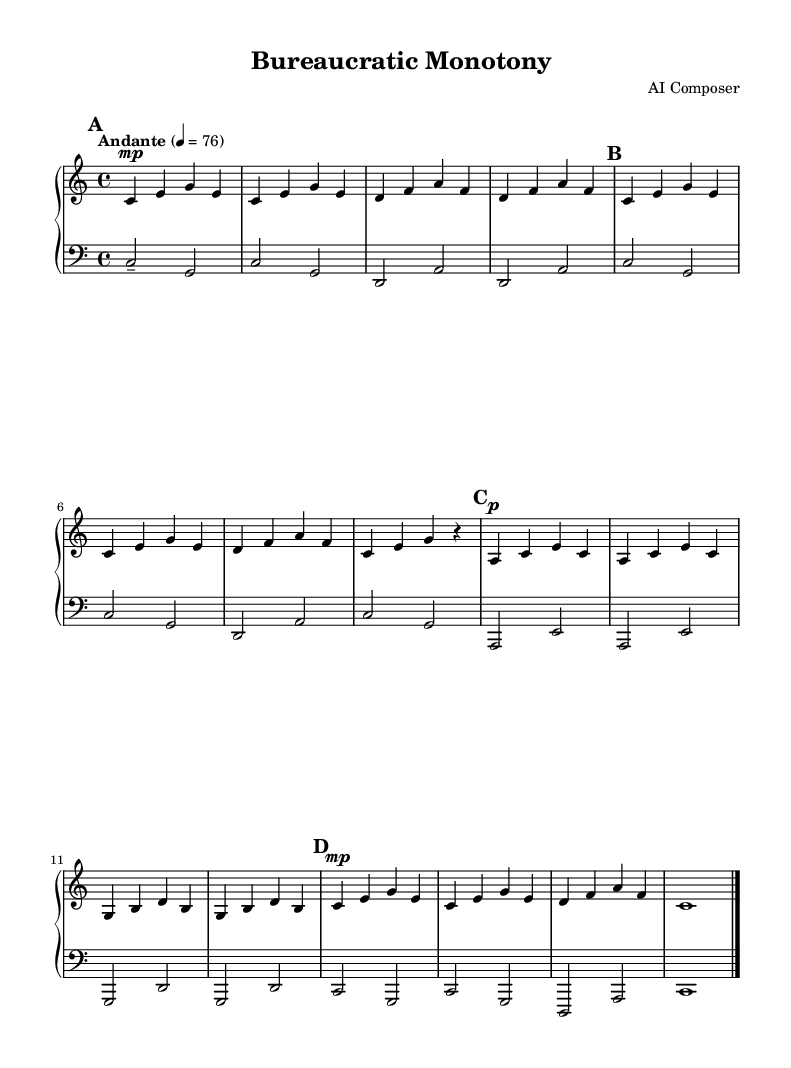What is the key signature of this music? The key signature of the music is indicated by the first clef section, where it shows no sharps or flats. This corresponds to C major.
Answer: C major What is the time signature of this music? The time signature is displayed at the beginning of the score as a fraction and shows four beats per measure. This is represented as 4/4.
Answer: 4/4 What is the tempo marking of this piece? The tempo marking is written above the staff as "Andante" followed by a metronome indication of 76 beats per minute, which indicates a moderately slow tempo.
Answer: Andante 4 = 76 How many measures are in section A? To determine this, I count the measures explicitly written in the score for the section labeled "A." Section A consists of four measures.
Answer: 4 What note duration is the longest in this piece? Among the note values shown in the sheet music, the longest note duration is indicated at the end of section A with a whole note, using the symbol corresponding to a full measure.
Answer: Whole note How many times is the section labeled "B" repeated? The section labeled "B" appears once in the provided score, as I analyze the structure presented, which provides a straightforward sequence for each part.
Answer: Once Which musical instrument is specified for this score? The instrument is specified in both the right and left hand parts of the score with the marking "acoustic grand," indicating the type of piano instrument intended for the performance.
Answer: Acoustic grand 